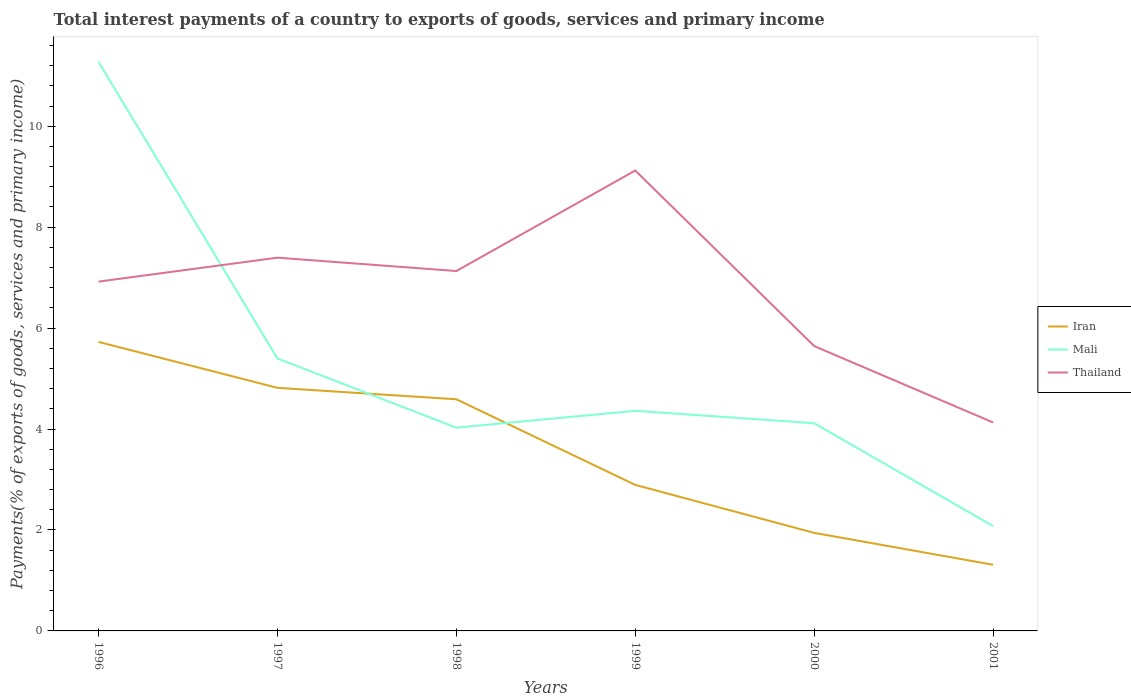Does the line corresponding to Thailand intersect with the line corresponding to Iran?
Provide a short and direct response. No. Is the number of lines equal to the number of legend labels?
Provide a short and direct response. Yes. Across all years, what is the maximum total interest payments in Mali?
Offer a terse response. 2.08. What is the total total interest payments in Mali in the graph?
Ensure brevity in your answer.  9.2. What is the difference between the highest and the second highest total interest payments in Thailand?
Make the answer very short. 4.99. What is the difference between the highest and the lowest total interest payments in Iran?
Your answer should be very brief. 3. How many years are there in the graph?
Your answer should be very brief. 6. What is the difference between two consecutive major ticks on the Y-axis?
Offer a very short reply. 2. Does the graph contain any zero values?
Offer a very short reply. No. Does the graph contain grids?
Ensure brevity in your answer.  No. Where does the legend appear in the graph?
Give a very brief answer. Center right. How many legend labels are there?
Ensure brevity in your answer.  3. What is the title of the graph?
Offer a very short reply. Total interest payments of a country to exports of goods, services and primary income. Does "Maldives" appear as one of the legend labels in the graph?
Offer a terse response. No. What is the label or title of the Y-axis?
Your response must be concise. Payments(% of exports of goods, services and primary income). What is the Payments(% of exports of goods, services and primary income) in Iran in 1996?
Give a very brief answer. 5.73. What is the Payments(% of exports of goods, services and primary income) of Mali in 1996?
Ensure brevity in your answer.  11.28. What is the Payments(% of exports of goods, services and primary income) in Thailand in 1996?
Provide a short and direct response. 6.92. What is the Payments(% of exports of goods, services and primary income) in Iran in 1997?
Give a very brief answer. 4.82. What is the Payments(% of exports of goods, services and primary income) in Mali in 1997?
Give a very brief answer. 5.4. What is the Payments(% of exports of goods, services and primary income) of Thailand in 1997?
Your answer should be very brief. 7.4. What is the Payments(% of exports of goods, services and primary income) of Iran in 1998?
Make the answer very short. 4.59. What is the Payments(% of exports of goods, services and primary income) of Mali in 1998?
Ensure brevity in your answer.  4.03. What is the Payments(% of exports of goods, services and primary income) in Thailand in 1998?
Your answer should be compact. 7.13. What is the Payments(% of exports of goods, services and primary income) of Iran in 1999?
Make the answer very short. 2.89. What is the Payments(% of exports of goods, services and primary income) in Mali in 1999?
Provide a succinct answer. 4.36. What is the Payments(% of exports of goods, services and primary income) in Thailand in 1999?
Keep it short and to the point. 9.12. What is the Payments(% of exports of goods, services and primary income) in Iran in 2000?
Make the answer very short. 1.94. What is the Payments(% of exports of goods, services and primary income) of Mali in 2000?
Your response must be concise. 4.12. What is the Payments(% of exports of goods, services and primary income) in Thailand in 2000?
Give a very brief answer. 5.64. What is the Payments(% of exports of goods, services and primary income) in Iran in 2001?
Offer a terse response. 1.31. What is the Payments(% of exports of goods, services and primary income) of Mali in 2001?
Give a very brief answer. 2.08. What is the Payments(% of exports of goods, services and primary income) in Thailand in 2001?
Ensure brevity in your answer.  4.13. Across all years, what is the maximum Payments(% of exports of goods, services and primary income) in Iran?
Give a very brief answer. 5.73. Across all years, what is the maximum Payments(% of exports of goods, services and primary income) of Mali?
Provide a succinct answer. 11.28. Across all years, what is the maximum Payments(% of exports of goods, services and primary income) in Thailand?
Give a very brief answer. 9.12. Across all years, what is the minimum Payments(% of exports of goods, services and primary income) of Iran?
Keep it short and to the point. 1.31. Across all years, what is the minimum Payments(% of exports of goods, services and primary income) of Mali?
Offer a terse response. 2.08. Across all years, what is the minimum Payments(% of exports of goods, services and primary income) of Thailand?
Your response must be concise. 4.13. What is the total Payments(% of exports of goods, services and primary income) in Iran in the graph?
Offer a very short reply. 21.28. What is the total Payments(% of exports of goods, services and primary income) in Mali in the graph?
Ensure brevity in your answer.  31.26. What is the total Payments(% of exports of goods, services and primary income) of Thailand in the graph?
Make the answer very short. 40.35. What is the difference between the Payments(% of exports of goods, services and primary income) of Iran in 1996 and that in 1997?
Your answer should be compact. 0.91. What is the difference between the Payments(% of exports of goods, services and primary income) in Mali in 1996 and that in 1997?
Make the answer very short. 5.88. What is the difference between the Payments(% of exports of goods, services and primary income) in Thailand in 1996 and that in 1997?
Keep it short and to the point. -0.47. What is the difference between the Payments(% of exports of goods, services and primary income) of Iran in 1996 and that in 1998?
Make the answer very short. 1.14. What is the difference between the Payments(% of exports of goods, services and primary income) of Mali in 1996 and that in 1998?
Your answer should be very brief. 7.25. What is the difference between the Payments(% of exports of goods, services and primary income) in Thailand in 1996 and that in 1998?
Offer a terse response. -0.21. What is the difference between the Payments(% of exports of goods, services and primary income) of Iran in 1996 and that in 1999?
Your answer should be very brief. 2.83. What is the difference between the Payments(% of exports of goods, services and primary income) in Mali in 1996 and that in 1999?
Ensure brevity in your answer.  6.92. What is the difference between the Payments(% of exports of goods, services and primary income) of Thailand in 1996 and that in 1999?
Your response must be concise. -2.2. What is the difference between the Payments(% of exports of goods, services and primary income) in Iran in 1996 and that in 2000?
Offer a terse response. 3.78. What is the difference between the Payments(% of exports of goods, services and primary income) in Mali in 1996 and that in 2000?
Provide a succinct answer. 7.16. What is the difference between the Payments(% of exports of goods, services and primary income) of Thailand in 1996 and that in 2000?
Your answer should be very brief. 1.28. What is the difference between the Payments(% of exports of goods, services and primary income) of Iran in 1996 and that in 2001?
Keep it short and to the point. 4.42. What is the difference between the Payments(% of exports of goods, services and primary income) in Mali in 1996 and that in 2001?
Your answer should be very brief. 9.2. What is the difference between the Payments(% of exports of goods, services and primary income) of Thailand in 1996 and that in 2001?
Make the answer very short. 2.79. What is the difference between the Payments(% of exports of goods, services and primary income) in Iran in 1997 and that in 1998?
Your answer should be very brief. 0.23. What is the difference between the Payments(% of exports of goods, services and primary income) of Mali in 1997 and that in 1998?
Make the answer very short. 1.37. What is the difference between the Payments(% of exports of goods, services and primary income) of Thailand in 1997 and that in 1998?
Make the answer very short. 0.26. What is the difference between the Payments(% of exports of goods, services and primary income) in Iran in 1997 and that in 1999?
Keep it short and to the point. 1.92. What is the difference between the Payments(% of exports of goods, services and primary income) in Mali in 1997 and that in 1999?
Offer a terse response. 1.04. What is the difference between the Payments(% of exports of goods, services and primary income) in Thailand in 1997 and that in 1999?
Provide a short and direct response. -1.73. What is the difference between the Payments(% of exports of goods, services and primary income) in Iran in 1997 and that in 2000?
Your response must be concise. 2.87. What is the difference between the Payments(% of exports of goods, services and primary income) in Mali in 1997 and that in 2000?
Your answer should be very brief. 1.28. What is the difference between the Payments(% of exports of goods, services and primary income) of Thailand in 1997 and that in 2000?
Your response must be concise. 1.75. What is the difference between the Payments(% of exports of goods, services and primary income) of Iran in 1997 and that in 2001?
Make the answer very short. 3.51. What is the difference between the Payments(% of exports of goods, services and primary income) of Mali in 1997 and that in 2001?
Your response must be concise. 3.32. What is the difference between the Payments(% of exports of goods, services and primary income) in Thailand in 1997 and that in 2001?
Provide a succinct answer. 3.27. What is the difference between the Payments(% of exports of goods, services and primary income) of Iran in 1998 and that in 1999?
Keep it short and to the point. 1.7. What is the difference between the Payments(% of exports of goods, services and primary income) in Mali in 1998 and that in 1999?
Make the answer very short. -0.33. What is the difference between the Payments(% of exports of goods, services and primary income) of Thailand in 1998 and that in 1999?
Offer a very short reply. -1.99. What is the difference between the Payments(% of exports of goods, services and primary income) of Iran in 1998 and that in 2000?
Keep it short and to the point. 2.65. What is the difference between the Payments(% of exports of goods, services and primary income) in Mali in 1998 and that in 2000?
Offer a terse response. -0.09. What is the difference between the Payments(% of exports of goods, services and primary income) of Thailand in 1998 and that in 2000?
Your answer should be very brief. 1.49. What is the difference between the Payments(% of exports of goods, services and primary income) in Iran in 1998 and that in 2001?
Your answer should be very brief. 3.28. What is the difference between the Payments(% of exports of goods, services and primary income) in Mali in 1998 and that in 2001?
Your answer should be very brief. 1.95. What is the difference between the Payments(% of exports of goods, services and primary income) in Thailand in 1998 and that in 2001?
Make the answer very short. 3. What is the difference between the Payments(% of exports of goods, services and primary income) in Iran in 1999 and that in 2000?
Your answer should be compact. 0.95. What is the difference between the Payments(% of exports of goods, services and primary income) of Mali in 1999 and that in 2000?
Keep it short and to the point. 0.25. What is the difference between the Payments(% of exports of goods, services and primary income) in Thailand in 1999 and that in 2000?
Offer a terse response. 3.48. What is the difference between the Payments(% of exports of goods, services and primary income) in Iran in 1999 and that in 2001?
Ensure brevity in your answer.  1.58. What is the difference between the Payments(% of exports of goods, services and primary income) of Mali in 1999 and that in 2001?
Keep it short and to the point. 2.28. What is the difference between the Payments(% of exports of goods, services and primary income) in Thailand in 1999 and that in 2001?
Make the answer very short. 4.99. What is the difference between the Payments(% of exports of goods, services and primary income) in Iran in 2000 and that in 2001?
Your response must be concise. 0.63. What is the difference between the Payments(% of exports of goods, services and primary income) in Mali in 2000 and that in 2001?
Provide a short and direct response. 2.04. What is the difference between the Payments(% of exports of goods, services and primary income) in Thailand in 2000 and that in 2001?
Make the answer very short. 1.51. What is the difference between the Payments(% of exports of goods, services and primary income) of Iran in 1996 and the Payments(% of exports of goods, services and primary income) of Mali in 1997?
Your response must be concise. 0.33. What is the difference between the Payments(% of exports of goods, services and primary income) of Iran in 1996 and the Payments(% of exports of goods, services and primary income) of Thailand in 1997?
Offer a very short reply. -1.67. What is the difference between the Payments(% of exports of goods, services and primary income) in Mali in 1996 and the Payments(% of exports of goods, services and primary income) in Thailand in 1997?
Your response must be concise. 3.88. What is the difference between the Payments(% of exports of goods, services and primary income) in Iran in 1996 and the Payments(% of exports of goods, services and primary income) in Mali in 1998?
Provide a short and direct response. 1.7. What is the difference between the Payments(% of exports of goods, services and primary income) in Iran in 1996 and the Payments(% of exports of goods, services and primary income) in Thailand in 1998?
Provide a short and direct response. -1.4. What is the difference between the Payments(% of exports of goods, services and primary income) in Mali in 1996 and the Payments(% of exports of goods, services and primary income) in Thailand in 1998?
Offer a very short reply. 4.15. What is the difference between the Payments(% of exports of goods, services and primary income) in Iran in 1996 and the Payments(% of exports of goods, services and primary income) in Mali in 1999?
Offer a terse response. 1.37. What is the difference between the Payments(% of exports of goods, services and primary income) in Iran in 1996 and the Payments(% of exports of goods, services and primary income) in Thailand in 1999?
Your answer should be compact. -3.4. What is the difference between the Payments(% of exports of goods, services and primary income) of Mali in 1996 and the Payments(% of exports of goods, services and primary income) of Thailand in 1999?
Provide a succinct answer. 2.16. What is the difference between the Payments(% of exports of goods, services and primary income) of Iran in 1996 and the Payments(% of exports of goods, services and primary income) of Mali in 2000?
Make the answer very short. 1.61. What is the difference between the Payments(% of exports of goods, services and primary income) of Iran in 1996 and the Payments(% of exports of goods, services and primary income) of Thailand in 2000?
Your answer should be compact. 0.08. What is the difference between the Payments(% of exports of goods, services and primary income) of Mali in 1996 and the Payments(% of exports of goods, services and primary income) of Thailand in 2000?
Keep it short and to the point. 5.63. What is the difference between the Payments(% of exports of goods, services and primary income) of Iran in 1996 and the Payments(% of exports of goods, services and primary income) of Mali in 2001?
Ensure brevity in your answer.  3.65. What is the difference between the Payments(% of exports of goods, services and primary income) of Iran in 1996 and the Payments(% of exports of goods, services and primary income) of Thailand in 2001?
Give a very brief answer. 1.6. What is the difference between the Payments(% of exports of goods, services and primary income) in Mali in 1996 and the Payments(% of exports of goods, services and primary income) in Thailand in 2001?
Your answer should be very brief. 7.15. What is the difference between the Payments(% of exports of goods, services and primary income) in Iran in 1997 and the Payments(% of exports of goods, services and primary income) in Mali in 1998?
Provide a succinct answer. 0.79. What is the difference between the Payments(% of exports of goods, services and primary income) in Iran in 1997 and the Payments(% of exports of goods, services and primary income) in Thailand in 1998?
Your response must be concise. -2.31. What is the difference between the Payments(% of exports of goods, services and primary income) of Mali in 1997 and the Payments(% of exports of goods, services and primary income) of Thailand in 1998?
Keep it short and to the point. -1.73. What is the difference between the Payments(% of exports of goods, services and primary income) in Iran in 1997 and the Payments(% of exports of goods, services and primary income) in Mali in 1999?
Make the answer very short. 0.46. What is the difference between the Payments(% of exports of goods, services and primary income) in Iran in 1997 and the Payments(% of exports of goods, services and primary income) in Thailand in 1999?
Make the answer very short. -4.31. What is the difference between the Payments(% of exports of goods, services and primary income) in Mali in 1997 and the Payments(% of exports of goods, services and primary income) in Thailand in 1999?
Keep it short and to the point. -3.72. What is the difference between the Payments(% of exports of goods, services and primary income) in Iran in 1997 and the Payments(% of exports of goods, services and primary income) in Mali in 2000?
Offer a terse response. 0.7. What is the difference between the Payments(% of exports of goods, services and primary income) in Iran in 1997 and the Payments(% of exports of goods, services and primary income) in Thailand in 2000?
Your answer should be very brief. -0.83. What is the difference between the Payments(% of exports of goods, services and primary income) of Mali in 1997 and the Payments(% of exports of goods, services and primary income) of Thailand in 2000?
Your answer should be compact. -0.24. What is the difference between the Payments(% of exports of goods, services and primary income) in Iran in 1997 and the Payments(% of exports of goods, services and primary income) in Mali in 2001?
Offer a terse response. 2.74. What is the difference between the Payments(% of exports of goods, services and primary income) of Iran in 1997 and the Payments(% of exports of goods, services and primary income) of Thailand in 2001?
Your answer should be compact. 0.69. What is the difference between the Payments(% of exports of goods, services and primary income) of Mali in 1997 and the Payments(% of exports of goods, services and primary income) of Thailand in 2001?
Give a very brief answer. 1.27. What is the difference between the Payments(% of exports of goods, services and primary income) of Iran in 1998 and the Payments(% of exports of goods, services and primary income) of Mali in 1999?
Ensure brevity in your answer.  0.23. What is the difference between the Payments(% of exports of goods, services and primary income) of Iran in 1998 and the Payments(% of exports of goods, services and primary income) of Thailand in 1999?
Ensure brevity in your answer.  -4.53. What is the difference between the Payments(% of exports of goods, services and primary income) of Mali in 1998 and the Payments(% of exports of goods, services and primary income) of Thailand in 1999?
Provide a short and direct response. -5.09. What is the difference between the Payments(% of exports of goods, services and primary income) in Iran in 1998 and the Payments(% of exports of goods, services and primary income) in Mali in 2000?
Offer a terse response. 0.47. What is the difference between the Payments(% of exports of goods, services and primary income) of Iran in 1998 and the Payments(% of exports of goods, services and primary income) of Thailand in 2000?
Make the answer very short. -1.05. What is the difference between the Payments(% of exports of goods, services and primary income) of Mali in 1998 and the Payments(% of exports of goods, services and primary income) of Thailand in 2000?
Provide a succinct answer. -1.62. What is the difference between the Payments(% of exports of goods, services and primary income) of Iran in 1998 and the Payments(% of exports of goods, services and primary income) of Mali in 2001?
Ensure brevity in your answer.  2.51. What is the difference between the Payments(% of exports of goods, services and primary income) in Iran in 1998 and the Payments(% of exports of goods, services and primary income) in Thailand in 2001?
Provide a short and direct response. 0.46. What is the difference between the Payments(% of exports of goods, services and primary income) in Mali in 1998 and the Payments(% of exports of goods, services and primary income) in Thailand in 2001?
Your answer should be compact. -0.1. What is the difference between the Payments(% of exports of goods, services and primary income) in Iran in 1999 and the Payments(% of exports of goods, services and primary income) in Mali in 2000?
Offer a terse response. -1.22. What is the difference between the Payments(% of exports of goods, services and primary income) in Iran in 1999 and the Payments(% of exports of goods, services and primary income) in Thailand in 2000?
Make the answer very short. -2.75. What is the difference between the Payments(% of exports of goods, services and primary income) in Mali in 1999 and the Payments(% of exports of goods, services and primary income) in Thailand in 2000?
Your response must be concise. -1.28. What is the difference between the Payments(% of exports of goods, services and primary income) in Iran in 1999 and the Payments(% of exports of goods, services and primary income) in Mali in 2001?
Your answer should be very brief. 0.82. What is the difference between the Payments(% of exports of goods, services and primary income) in Iran in 1999 and the Payments(% of exports of goods, services and primary income) in Thailand in 2001?
Your answer should be compact. -1.24. What is the difference between the Payments(% of exports of goods, services and primary income) in Mali in 1999 and the Payments(% of exports of goods, services and primary income) in Thailand in 2001?
Ensure brevity in your answer.  0.23. What is the difference between the Payments(% of exports of goods, services and primary income) in Iran in 2000 and the Payments(% of exports of goods, services and primary income) in Mali in 2001?
Provide a short and direct response. -0.13. What is the difference between the Payments(% of exports of goods, services and primary income) of Iran in 2000 and the Payments(% of exports of goods, services and primary income) of Thailand in 2001?
Your answer should be very brief. -2.19. What is the difference between the Payments(% of exports of goods, services and primary income) in Mali in 2000 and the Payments(% of exports of goods, services and primary income) in Thailand in 2001?
Provide a succinct answer. -0.01. What is the average Payments(% of exports of goods, services and primary income) of Iran per year?
Your answer should be very brief. 3.55. What is the average Payments(% of exports of goods, services and primary income) in Mali per year?
Provide a succinct answer. 5.21. What is the average Payments(% of exports of goods, services and primary income) of Thailand per year?
Offer a terse response. 6.72. In the year 1996, what is the difference between the Payments(% of exports of goods, services and primary income) of Iran and Payments(% of exports of goods, services and primary income) of Mali?
Make the answer very short. -5.55. In the year 1996, what is the difference between the Payments(% of exports of goods, services and primary income) of Iran and Payments(% of exports of goods, services and primary income) of Thailand?
Give a very brief answer. -1.19. In the year 1996, what is the difference between the Payments(% of exports of goods, services and primary income) in Mali and Payments(% of exports of goods, services and primary income) in Thailand?
Keep it short and to the point. 4.36. In the year 1997, what is the difference between the Payments(% of exports of goods, services and primary income) in Iran and Payments(% of exports of goods, services and primary income) in Mali?
Your response must be concise. -0.58. In the year 1997, what is the difference between the Payments(% of exports of goods, services and primary income) in Iran and Payments(% of exports of goods, services and primary income) in Thailand?
Your answer should be compact. -2.58. In the year 1997, what is the difference between the Payments(% of exports of goods, services and primary income) in Mali and Payments(% of exports of goods, services and primary income) in Thailand?
Offer a very short reply. -2. In the year 1998, what is the difference between the Payments(% of exports of goods, services and primary income) of Iran and Payments(% of exports of goods, services and primary income) of Mali?
Your response must be concise. 0.56. In the year 1998, what is the difference between the Payments(% of exports of goods, services and primary income) in Iran and Payments(% of exports of goods, services and primary income) in Thailand?
Keep it short and to the point. -2.54. In the year 1998, what is the difference between the Payments(% of exports of goods, services and primary income) in Mali and Payments(% of exports of goods, services and primary income) in Thailand?
Provide a short and direct response. -3.1. In the year 1999, what is the difference between the Payments(% of exports of goods, services and primary income) of Iran and Payments(% of exports of goods, services and primary income) of Mali?
Give a very brief answer. -1.47. In the year 1999, what is the difference between the Payments(% of exports of goods, services and primary income) of Iran and Payments(% of exports of goods, services and primary income) of Thailand?
Offer a very short reply. -6.23. In the year 1999, what is the difference between the Payments(% of exports of goods, services and primary income) in Mali and Payments(% of exports of goods, services and primary income) in Thailand?
Provide a short and direct response. -4.76. In the year 2000, what is the difference between the Payments(% of exports of goods, services and primary income) in Iran and Payments(% of exports of goods, services and primary income) in Mali?
Your answer should be compact. -2.17. In the year 2000, what is the difference between the Payments(% of exports of goods, services and primary income) of Iran and Payments(% of exports of goods, services and primary income) of Thailand?
Your answer should be very brief. -3.7. In the year 2000, what is the difference between the Payments(% of exports of goods, services and primary income) in Mali and Payments(% of exports of goods, services and primary income) in Thailand?
Give a very brief answer. -1.53. In the year 2001, what is the difference between the Payments(% of exports of goods, services and primary income) of Iran and Payments(% of exports of goods, services and primary income) of Mali?
Ensure brevity in your answer.  -0.77. In the year 2001, what is the difference between the Payments(% of exports of goods, services and primary income) in Iran and Payments(% of exports of goods, services and primary income) in Thailand?
Make the answer very short. -2.82. In the year 2001, what is the difference between the Payments(% of exports of goods, services and primary income) in Mali and Payments(% of exports of goods, services and primary income) in Thailand?
Make the answer very short. -2.05. What is the ratio of the Payments(% of exports of goods, services and primary income) in Iran in 1996 to that in 1997?
Give a very brief answer. 1.19. What is the ratio of the Payments(% of exports of goods, services and primary income) of Mali in 1996 to that in 1997?
Offer a terse response. 2.09. What is the ratio of the Payments(% of exports of goods, services and primary income) of Thailand in 1996 to that in 1997?
Keep it short and to the point. 0.94. What is the ratio of the Payments(% of exports of goods, services and primary income) in Iran in 1996 to that in 1998?
Your answer should be very brief. 1.25. What is the ratio of the Payments(% of exports of goods, services and primary income) of Mali in 1996 to that in 1998?
Ensure brevity in your answer.  2.8. What is the ratio of the Payments(% of exports of goods, services and primary income) of Thailand in 1996 to that in 1998?
Provide a short and direct response. 0.97. What is the ratio of the Payments(% of exports of goods, services and primary income) of Iran in 1996 to that in 1999?
Provide a short and direct response. 1.98. What is the ratio of the Payments(% of exports of goods, services and primary income) of Mali in 1996 to that in 1999?
Make the answer very short. 2.59. What is the ratio of the Payments(% of exports of goods, services and primary income) in Thailand in 1996 to that in 1999?
Keep it short and to the point. 0.76. What is the ratio of the Payments(% of exports of goods, services and primary income) of Iran in 1996 to that in 2000?
Provide a short and direct response. 2.95. What is the ratio of the Payments(% of exports of goods, services and primary income) in Mali in 1996 to that in 2000?
Provide a succinct answer. 2.74. What is the ratio of the Payments(% of exports of goods, services and primary income) in Thailand in 1996 to that in 2000?
Your response must be concise. 1.23. What is the ratio of the Payments(% of exports of goods, services and primary income) of Iran in 1996 to that in 2001?
Ensure brevity in your answer.  4.37. What is the ratio of the Payments(% of exports of goods, services and primary income) of Mali in 1996 to that in 2001?
Make the answer very short. 5.43. What is the ratio of the Payments(% of exports of goods, services and primary income) of Thailand in 1996 to that in 2001?
Your response must be concise. 1.68. What is the ratio of the Payments(% of exports of goods, services and primary income) in Iran in 1997 to that in 1998?
Provide a short and direct response. 1.05. What is the ratio of the Payments(% of exports of goods, services and primary income) in Mali in 1997 to that in 1998?
Your answer should be compact. 1.34. What is the ratio of the Payments(% of exports of goods, services and primary income) in Thailand in 1997 to that in 1998?
Offer a very short reply. 1.04. What is the ratio of the Payments(% of exports of goods, services and primary income) of Iran in 1997 to that in 1999?
Give a very brief answer. 1.66. What is the ratio of the Payments(% of exports of goods, services and primary income) of Mali in 1997 to that in 1999?
Provide a short and direct response. 1.24. What is the ratio of the Payments(% of exports of goods, services and primary income) of Thailand in 1997 to that in 1999?
Make the answer very short. 0.81. What is the ratio of the Payments(% of exports of goods, services and primary income) of Iran in 1997 to that in 2000?
Offer a very short reply. 2.48. What is the ratio of the Payments(% of exports of goods, services and primary income) of Mali in 1997 to that in 2000?
Your response must be concise. 1.31. What is the ratio of the Payments(% of exports of goods, services and primary income) of Thailand in 1997 to that in 2000?
Your answer should be compact. 1.31. What is the ratio of the Payments(% of exports of goods, services and primary income) of Iran in 1997 to that in 2001?
Offer a terse response. 3.67. What is the ratio of the Payments(% of exports of goods, services and primary income) of Mali in 1997 to that in 2001?
Your response must be concise. 2.6. What is the ratio of the Payments(% of exports of goods, services and primary income) in Thailand in 1997 to that in 2001?
Provide a short and direct response. 1.79. What is the ratio of the Payments(% of exports of goods, services and primary income) in Iran in 1998 to that in 1999?
Make the answer very short. 1.59. What is the ratio of the Payments(% of exports of goods, services and primary income) of Mali in 1998 to that in 1999?
Provide a succinct answer. 0.92. What is the ratio of the Payments(% of exports of goods, services and primary income) in Thailand in 1998 to that in 1999?
Your response must be concise. 0.78. What is the ratio of the Payments(% of exports of goods, services and primary income) in Iran in 1998 to that in 2000?
Your response must be concise. 2.36. What is the ratio of the Payments(% of exports of goods, services and primary income) of Mali in 1998 to that in 2000?
Your answer should be very brief. 0.98. What is the ratio of the Payments(% of exports of goods, services and primary income) in Thailand in 1998 to that in 2000?
Provide a succinct answer. 1.26. What is the ratio of the Payments(% of exports of goods, services and primary income) of Iran in 1998 to that in 2001?
Provide a succinct answer. 3.5. What is the ratio of the Payments(% of exports of goods, services and primary income) of Mali in 1998 to that in 2001?
Provide a short and direct response. 1.94. What is the ratio of the Payments(% of exports of goods, services and primary income) of Thailand in 1998 to that in 2001?
Offer a very short reply. 1.73. What is the ratio of the Payments(% of exports of goods, services and primary income) in Iran in 1999 to that in 2000?
Make the answer very short. 1.49. What is the ratio of the Payments(% of exports of goods, services and primary income) in Mali in 1999 to that in 2000?
Provide a short and direct response. 1.06. What is the ratio of the Payments(% of exports of goods, services and primary income) in Thailand in 1999 to that in 2000?
Ensure brevity in your answer.  1.62. What is the ratio of the Payments(% of exports of goods, services and primary income) of Iran in 1999 to that in 2001?
Provide a succinct answer. 2.21. What is the ratio of the Payments(% of exports of goods, services and primary income) of Mali in 1999 to that in 2001?
Provide a short and direct response. 2.1. What is the ratio of the Payments(% of exports of goods, services and primary income) of Thailand in 1999 to that in 2001?
Provide a succinct answer. 2.21. What is the ratio of the Payments(% of exports of goods, services and primary income) of Iran in 2000 to that in 2001?
Keep it short and to the point. 1.48. What is the ratio of the Payments(% of exports of goods, services and primary income) of Mali in 2000 to that in 2001?
Provide a succinct answer. 1.98. What is the ratio of the Payments(% of exports of goods, services and primary income) of Thailand in 2000 to that in 2001?
Your answer should be very brief. 1.37. What is the difference between the highest and the second highest Payments(% of exports of goods, services and primary income) of Iran?
Give a very brief answer. 0.91. What is the difference between the highest and the second highest Payments(% of exports of goods, services and primary income) in Mali?
Offer a terse response. 5.88. What is the difference between the highest and the second highest Payments(% of exports of goods, services and primary income) of Thailand?
Keep it short and to the point. 1.73. What is the difference between the highest and the lowest Payments(% of exports of goods, services and primary income) in Iran?
Your answer should be compact. 4.42. What is the difference between the highest and the lowest Payments(% of exports of goods, services and primary income) of Mali?
Ensure brevity in your answer.  9.2. What is the difference between the highest and the lowest Payments(% of exports of goods, services and primary income) of Thailand?
Your answer should be very brief. 4.99. 